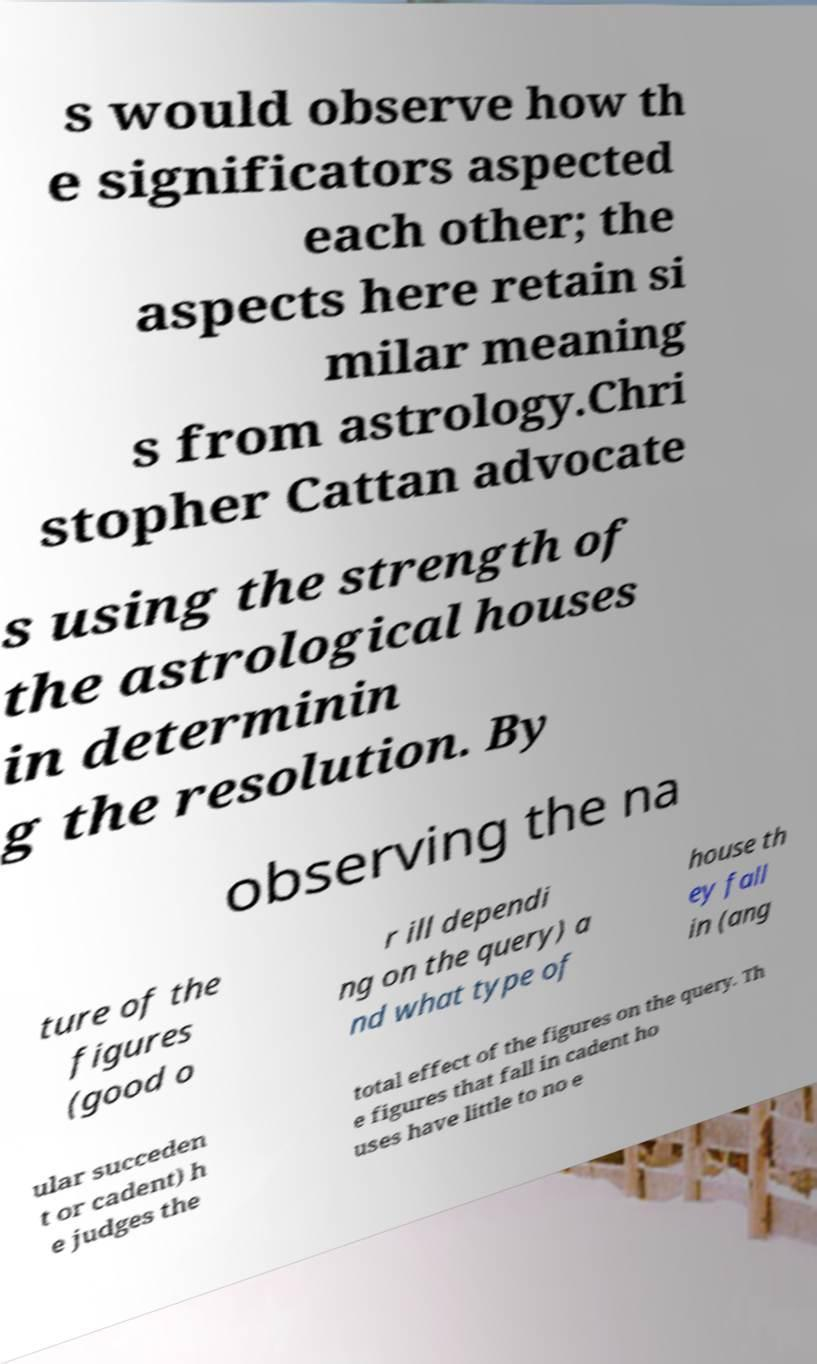Could you extract and type out the text from this image? s would observe how th e significators aspected each other; the aspects here retain si milar meaning s from astrology.Chri stopher Cattan advocate s using the strength of the astrological houses in determinin g the resolution. By observing the na ture of the figures (good o r ill dependi ng on the query) a nd what type of house th ey fall in (ang ular succeden t or cadent) h e judges the total effect of the figures on the query. Th e figures that fall in cadent ho uses have little to no e 